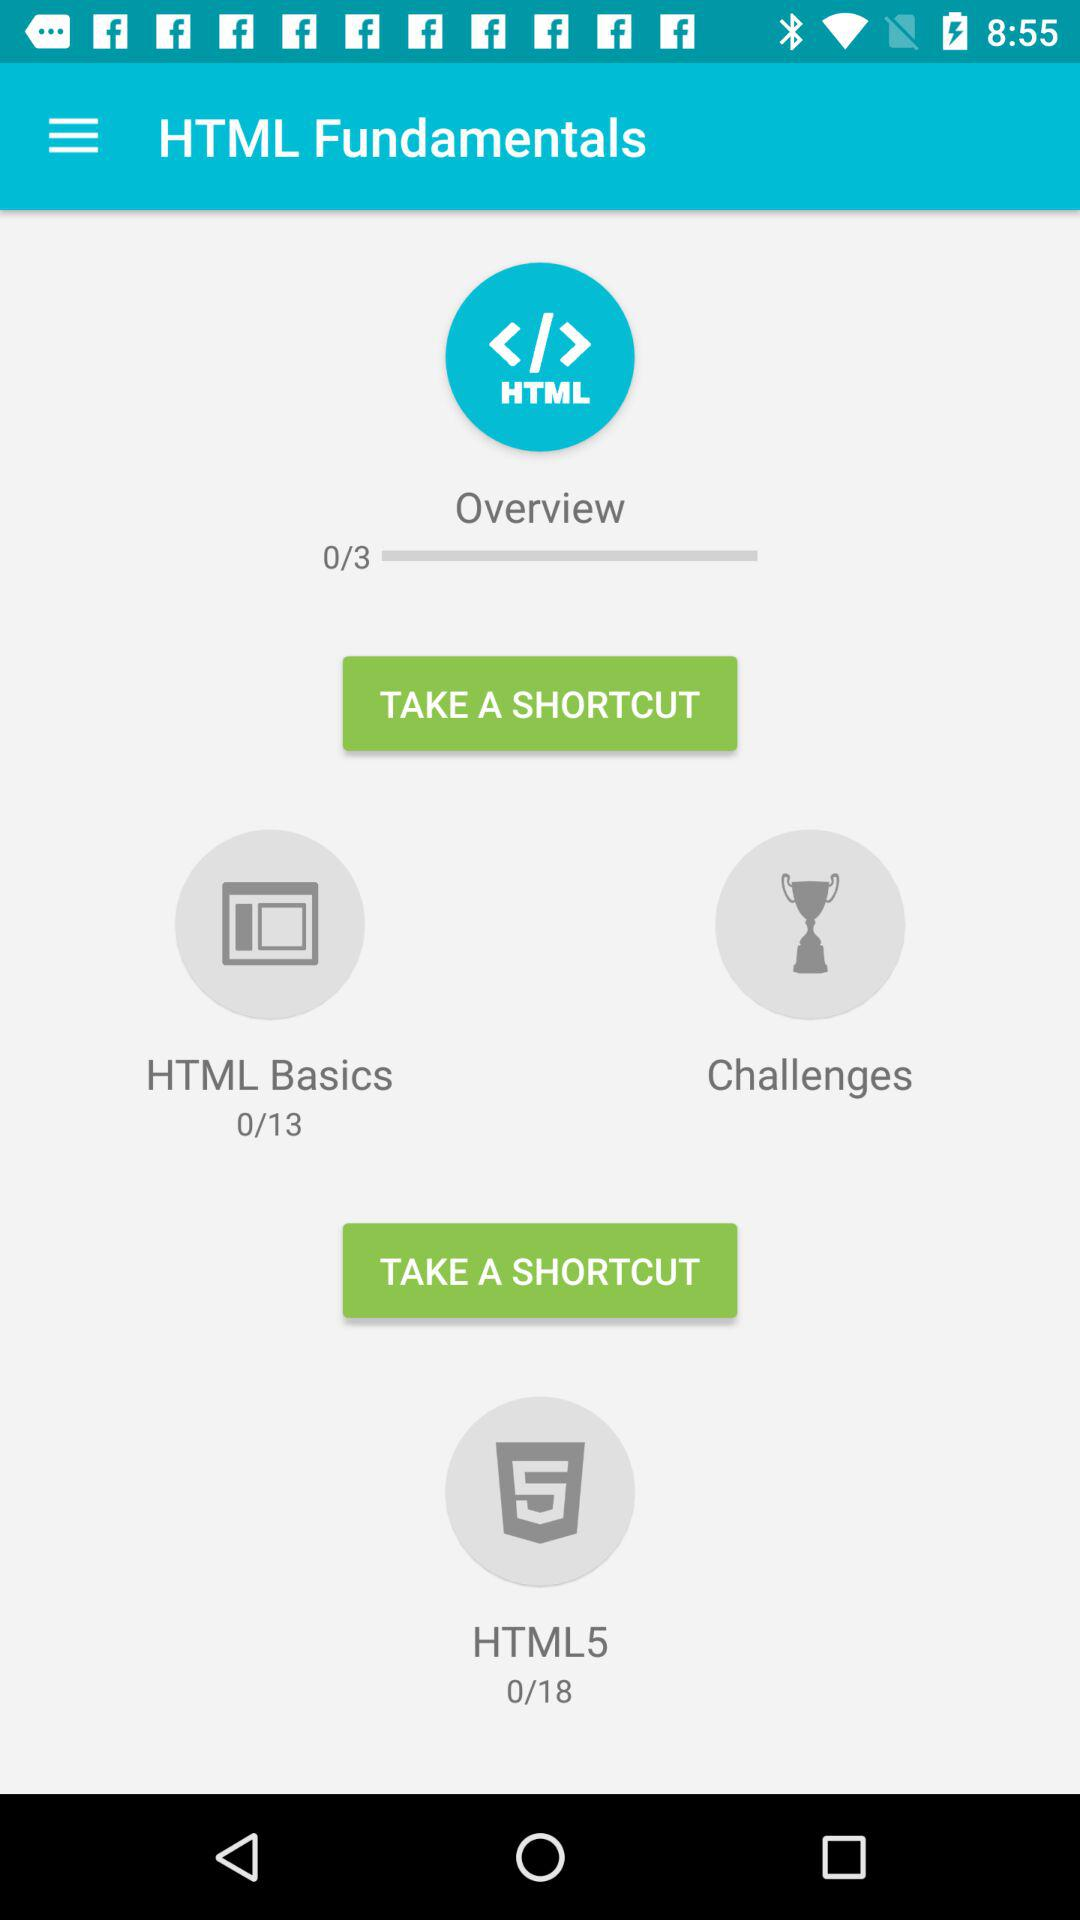In which topic three lectures are available? Three lectures are available in "Overview". 